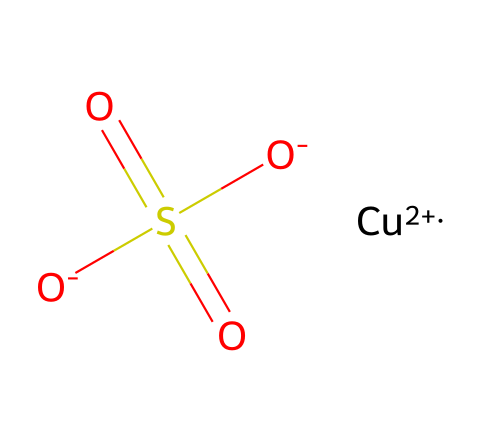What is the oxidation state of copper in this compound? In the SMILES representation, '[Cu+2]' indicates that copper is in the +2 oxidation state, which is crucial for its role in this chemical.
Answer: +2 How many oxygen atoms are present in the structure? Analyzing the SMILES notation, there are five oxygen atoms indicated, two in the sulfate group (O in [O-] and O in S(=O)(=O)) and an additional O in [O-].
Answer: 5 What functional group is present in copper sulfate? The presence of 'S(=O)(=O)' indicates the sulfate functional group (SO4), which is a defining feature of copper sulfate.
Answer: sulfate How many sulfur atoms are in this molecule? The SMILES representation shows a single 'S' in 'S(=O)(=O)', indicating there is one sulfur atom present in the structure.
Answer: 1 Is copper sulfate an organic or inorganic compound? Since copper sulfate is comprised of metal (copper) and non-metal (sulfur and oxygen) elements, it is categorized as an inorganic compound rather than containing carbon for organic compounds.
Answer: inorganic What is the primary agricultural use of copper sulfate? Copper sulfate is primarily used as a fungicide in agriculture to control fungal diseases in various crops.
Answer: fungicide How many total atoms are present in copper sulfate, including all types of atoms? By counting the atoms present: 1 copper, 1 sulfur, and 5 oxygen yields a total of 7 atoms in the molecule, combining all types present.
Answer: 7 